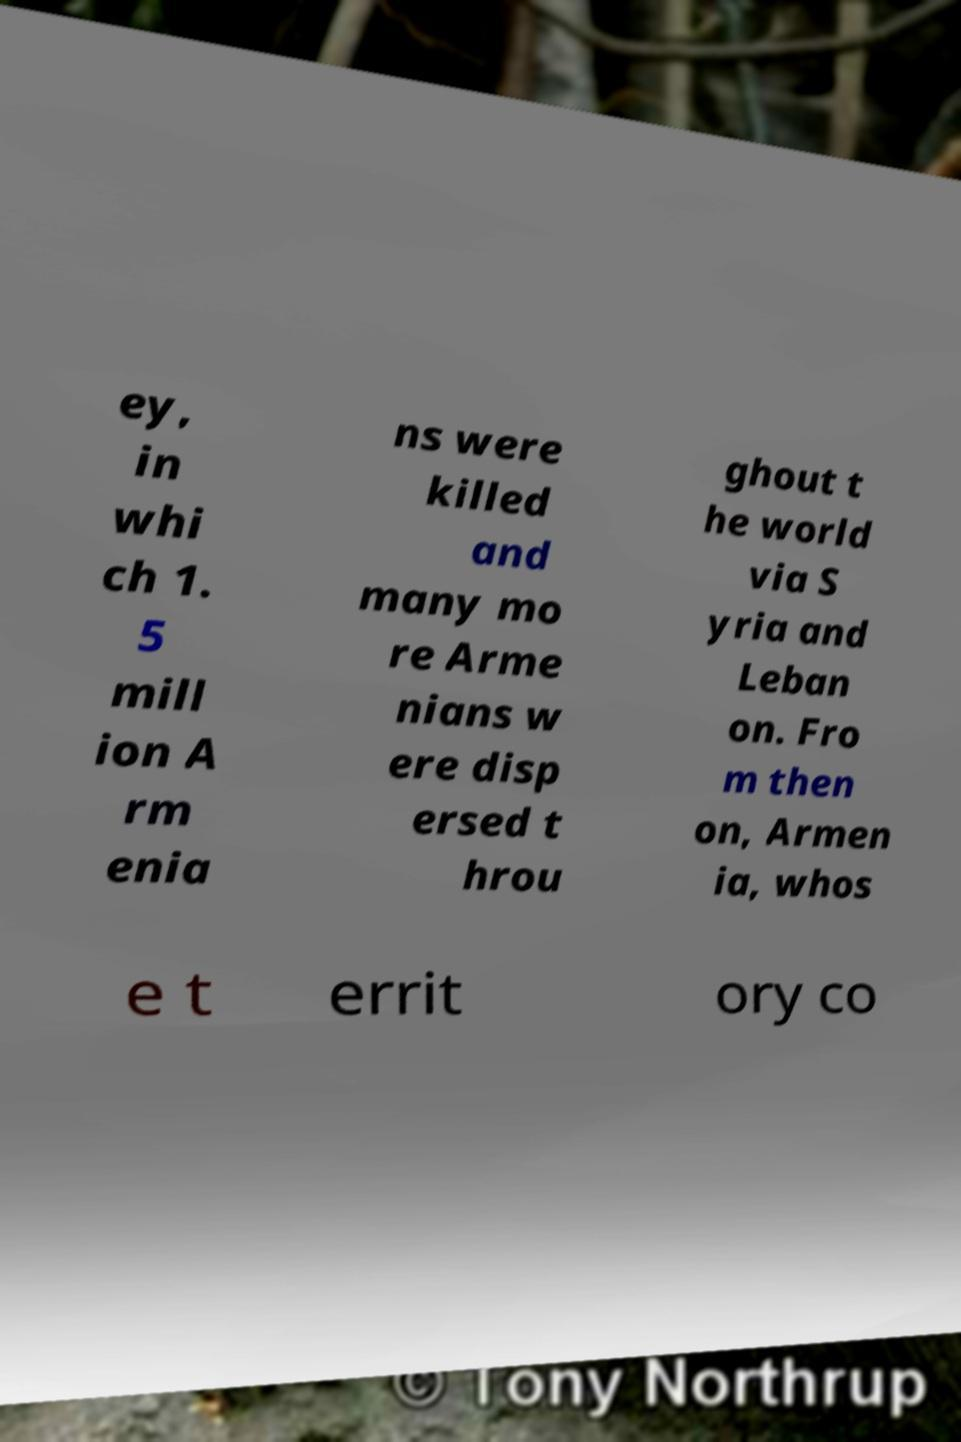Could you extract and type out the text from this image? ey, in whi ch 1. 5 mill ion A rm enia ns were killed and many mo re Arme nians w ere disp ersed t hrou ghout t he world via S yria and Leban on. Fro m then on, Armen ia, whos e t errit ory co 